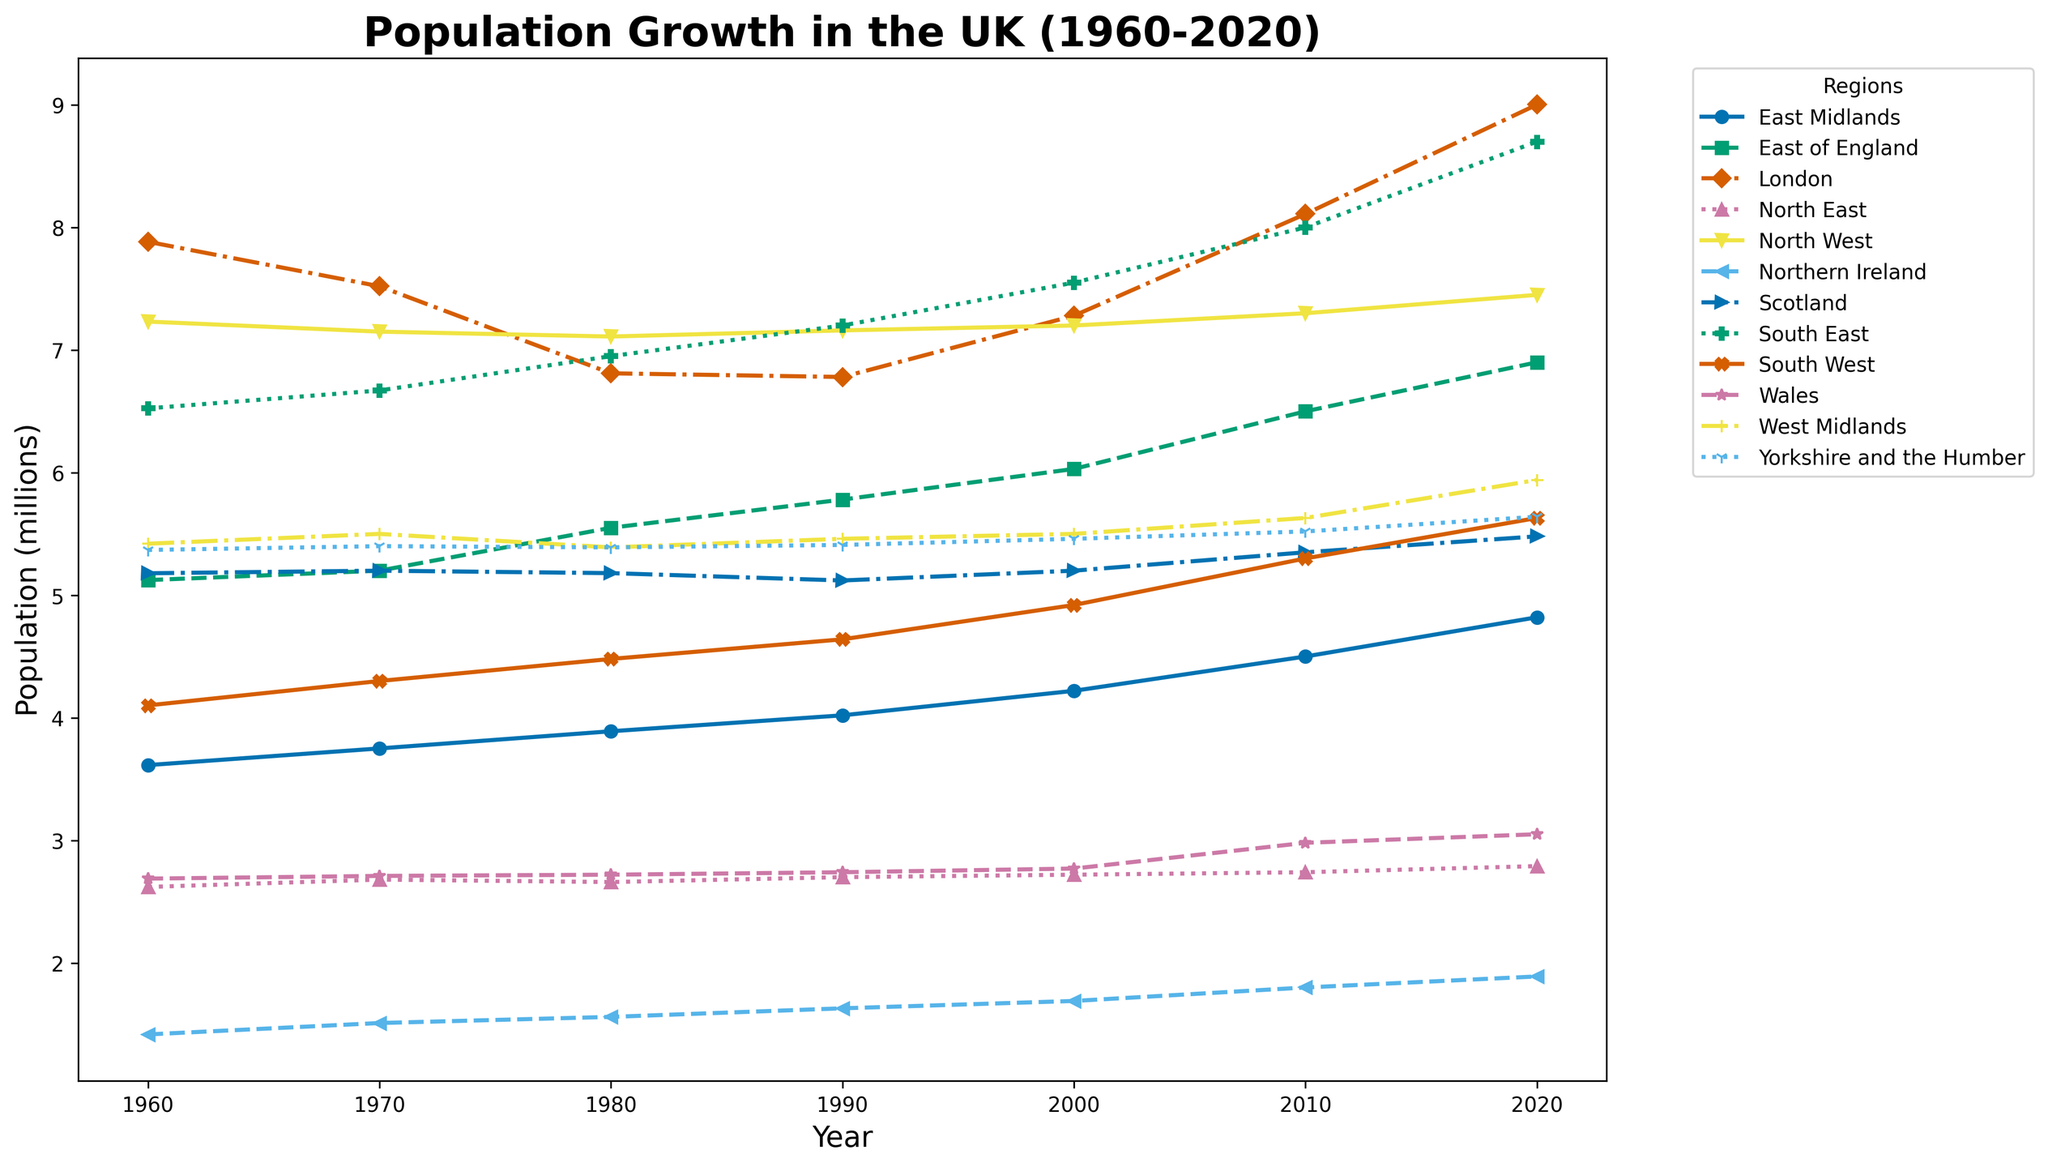What is the population difference between London and the South East in 2020? To find the difference, locate the population values for London and South East in 2020 from the graph. Subtract the South East population value from the London population value.
Answer: 0.302 million Which region had the highest population growth between 1960 and 2020? Identify the population values for each region in both 1960 and 2020 from the graph. Calculate the difference for each region (2020 value - 1960 value) and find the region with the greatest difference.
Answer: London What was the average population of Northern Ireland from 1960 to 2020? Locate the population values for Northern Ireland for the years listed: 1960, 1970, 1980, 1990, 2000, 2010, and 2020. Sum these values and divide by the number of data points (7).
Answer: 1.642 million How does the population growth trend of London compare to that of Scotland between 1960 and 2020? Observe the line representing London and the line representing Scotland. Compare their slopes over the years from 1960 to 2020. London’s line shows a sharper upward trend indicating faster population growth compared to the relatively flatter line for Scotland.
Answer: London grew faster Which regions had a population decrease between 1960 and 1980? Compare the population values in 1960 with those in 1980 for all regions. Identify regions where the 1980 value is lower than the 1960 value.
Answer: London, North West What is the population growth difference between East of England and South West from 2000 to 2020? Subtract the 2000 population value from the 2020 population value for both East of England and South West. Then, find the difference between these two growth figures. East of England growth: 0.87 million; South West growth: 0.71 million; Difference: 0.87 - 0.71.
Answer: 0.16 million Which region had the smallest population in the year 2000? Locate the population values for all regions in the year 2000 and identify the smallest value.
Answer: Northern Ireland How many regions had populations over 5 million in 2010? Count the number of regions with population values greater than 5 million according to the 2010 data points.
Answer: 7 regions What is the total population of the UK in 2020? Sum all the regional population values for the year 2020 given in the graph.
Answer: 56.353 million Between which two consecutive decades did London experience the most significant population increase? Calculate the population differences for London between each pair of consecutive decades (1970-1960, 1980-1970, etc.). The decade pair with the highest difference indicates the most significant increase.
Answer: 2010-2000 